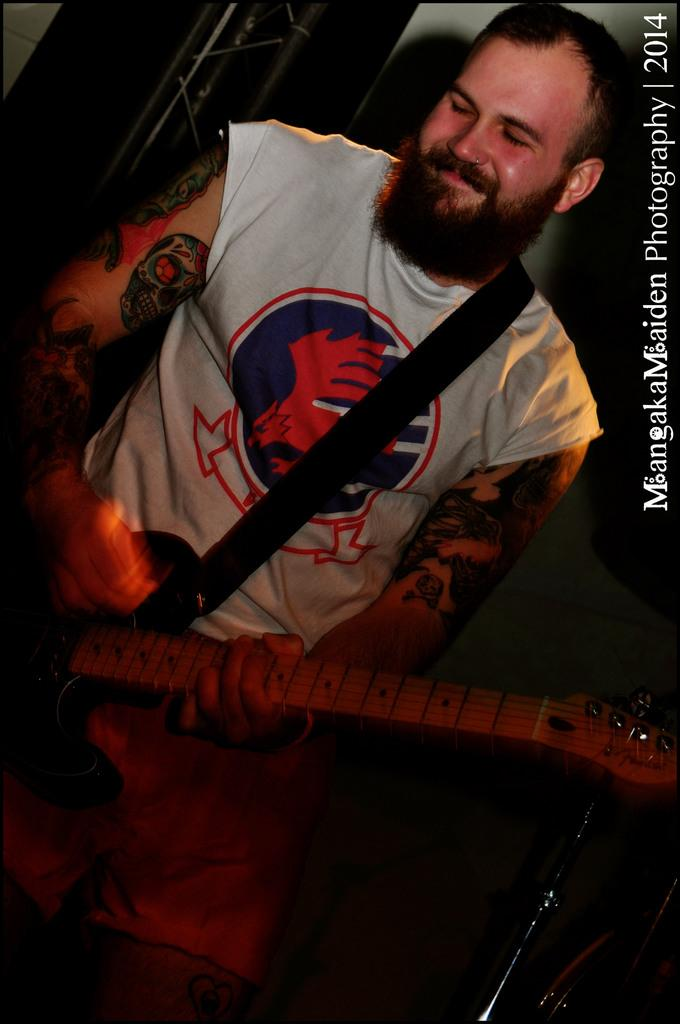What is the man in the image holding? The man is holding a guitar. What is the man's facial expression in the image? The man is smiling. What type of oil can be seen dripping from the man's guitar in the image? There is no oil dripping from the man's guitar in the image. What causes the man's guitar to burst in the image? The man's guitar does not burst in the image. 